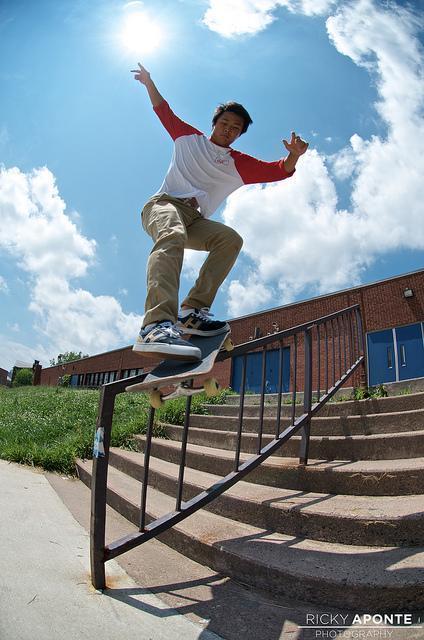How many skateboards are there?
Give a very brief answer. 1. How many of the baskets of food have forks in them?
Give a very brief answer. 0. 